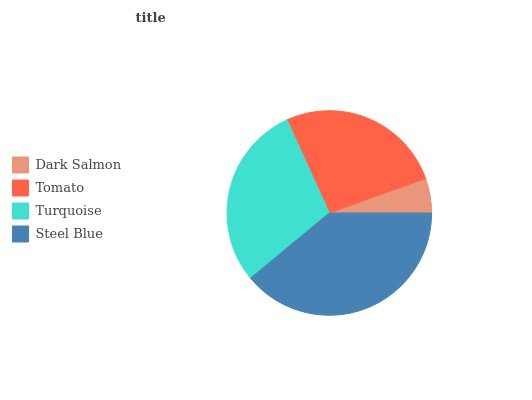Is Dark Salmon the minimum?
Answer yes or no. Yes. Is Steel Blue the maximum?
Answer yes or no. Yes. Is Tomato the minimum?
Answer yes or no. No. Is Tomato the maximum?
Answer yes or no. No. Is Tomato greater than Dark Salmon?
Answer yes or no. Yes. Is Dark Salmon less than Tomato?
Answer yes or no. Yes. Is Dark Salmon greater than Tomato?
Answer yes or no. No. Is Tomato less than Dark Salmon?
Answer yes or no. No. Is Turquoise the high median?
Answer yes or no. Yes. Is Tomato the low median?
Answer yes or no. Yes. Is Tomato the high median?
Answer yes or no. No. Is Dark Salmon the low median?
Answer yes or no. No. 